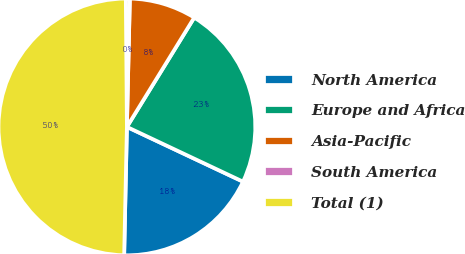Convert chart to OTSL. <chart><loc_0><loc_0><loc_500><loc_500><pie_chart><fcel>North America<fcel>Europe and Africa<fcel>Asia-Pacific<fcel>South America<fcel>Total (1)<nl><fcel>18.33%<fcel>23.23%<fcel>8.42%<fcel>0.5%<fcel>49.53%<nl></chart> 